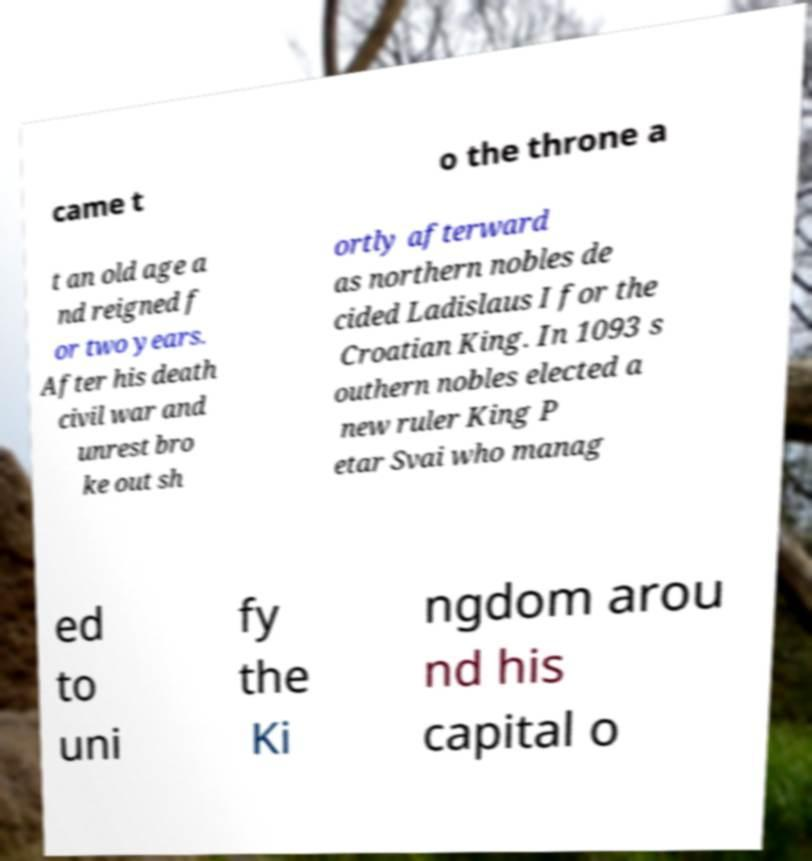What messages or text are displayed in this image? I need them in a readable, typed format. came t o the throne a t an old age a nd reigned f or two years. After his death civil war and unrest bro ke out sh ortly afterward as northern nobles de cided Ladislaus I for the Croatian King. In 1093 s outhern nobles elected a new ruler King P etar Svai who manag ed to uni fy the Ki ngdom arou nd his capital o 